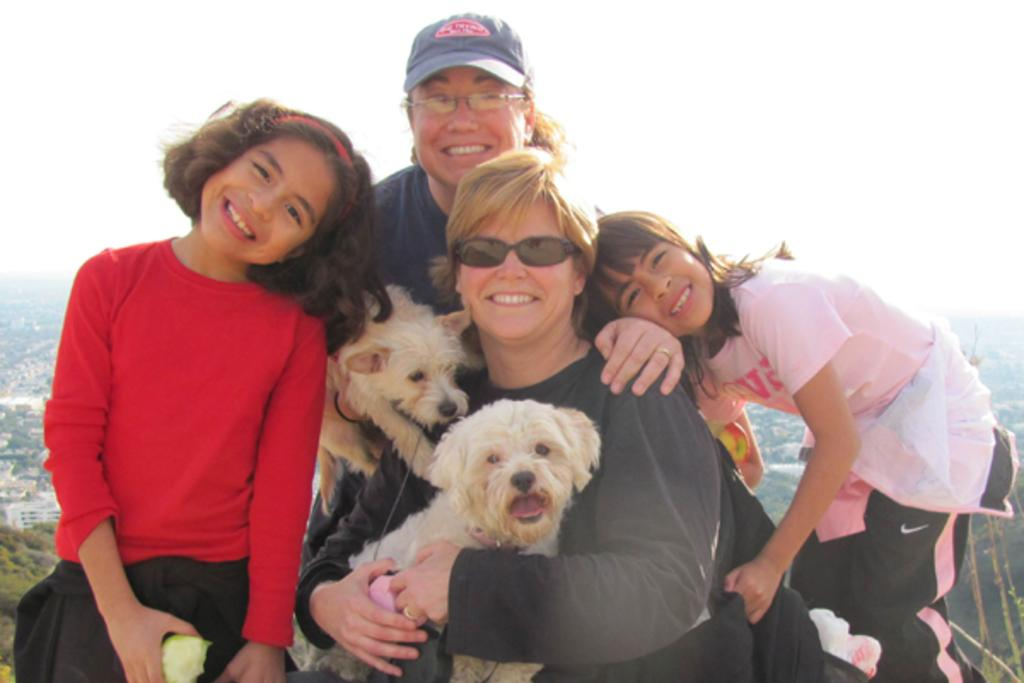What is the seated woman doing in the image? The seated woman is holding a dog in the image. What is the standing woman doing in the image? The standing woman is also holding a dog in the image. How many girls are present in the image? There are two girls standing on both sides in the image. What type of camera can be seen in the image? There is no camera present in the image. How does the growth of the dog compare to the growth of the girls in the image? There is no indication of the dog's or the girls' growth in the image, as it only shows them holding the dogs. 